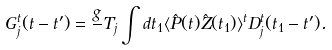Convert formula to latex. <formula><loc_0><loc_0><loc_500><loc_500>G _ { j } ^ { t } ( t - t ^ { \prime } ) = \frac { g } { } T _ { j } \int d t _ { 1 } \langle \hat { P } ( t ) \hat { Z } ( t _ { 1 } ) \rangle ^ { t } D _ { j } ^ { t } ( t _ { 1 } - t ^ { \prime } ) .</formula> 